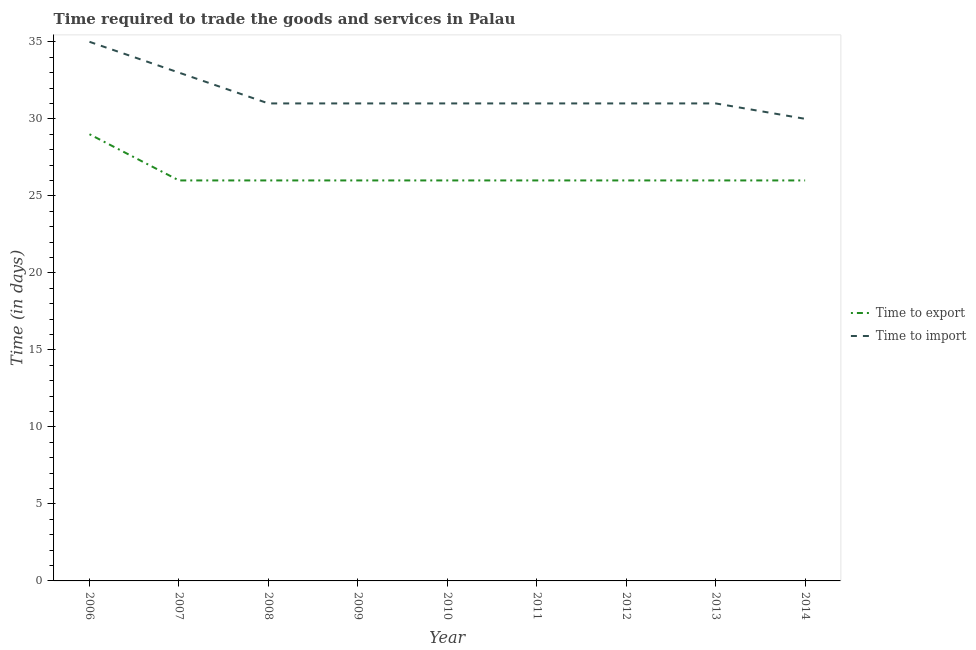How many different coloured lines are there?
Keep it short and to the point. 2. Is the number of lines equal to the number of legend labels?
Offer a very short reply. Yes. What is the time to import in 2014?
Offer a very short reply. 30. Across all years, what is the maximum time to import?
Your answer should be compact. 35. Across all years, what is the minimum time to export?
Provide a short and direct response. 26. In which year was the time to import minimum?
Keep it short and to the point. 2014. What is the total time to export in the graph?
Your answer should be compact. 237. What is the difference between the time to import in 2008 and that in 2009?
Your answer should be very brief. 0. What is the difference between the time to import in 2006 and the time to export in 2008?
Provide a short and direct response. 9. What is the average time to export per year?
Provide a succinct answer. 26.33. In the year 2010, what is the difference between the time to import and time to export?
Ensure brevity in your answer.  5. In how many years, is the time to import greater than 2 days?
Your answer should be very brief. 9. What is the ratio of the time to import in 2007 to that in 2010?
Offer a very short reply. 1.06. Is the time to export in 2006 less than that in 2008?
Your answer should be compact. No. Is the difference between the time to export in 2007 and 2011 greater than the difference between the time to import in 2007 and 2011?
Your answer should be very brief. No. What is the difference between the highest and the lowest time to import?
Your response must be concise. 5. Is the sum of the time to import in 2008 and 2012 greater than the maximum time to export across all years?
Make the answer very short. Yes. Does the time to export monotonically increase over the years?
Your answer should be compact. No. Is the time to import strictly greater than the time to export over the years?
Ensure brevity in your answer.  Yes. Is the time to import strictly less than the time to export over the years?
Your answer should be very brief. No. How many lines are there?
Your answer should be very brief. 2. Does the graph contain any zero values?
Provide a short and direct response. No. Does the graph contain grids?
Provide a short and direct response. No. How many legend labels are there?
Provide a succinct answer. 2. How are the legend labels stacked?
Provide a succinct answer. Vertical. What is the title of the graph?
Offer a terse response. Time required to trade the goods and services in Palau. Does "Commercial bank branches" appear as one of the legend labels in the graph?
Keep it short and to the point. No. What is the label or title of the X-axis?
Offer a very short reply. Year. What is the label or title of the Y-axis?
Your answer should be compact. Time (in days). What is the Time (in days) of Time to export in 2006?
Your answer should be very brief. 29. What is the Time (in days) in Time to import in 2006?
Offer a terse response. 35. What is the Time (in days) in Time to export in 2007?
Provide a succinct answer. 26. What is the Time (in days) of Time to import in 2008?
Your answer should be compact. 31. What is the Time (in days) in Time to export in 2009?
Ensure brevity in your answer.  26. What is the Time (in days) of Time to export in 2011?
Provide a short and direct response. 26. What is the Time (in days) of Time to import in 2011?
Your answer should be compact. 31. What is the Time (in days) in Time to import in 2013?
Give a very brief answer. 31. What is the Time (in days) in Time to import in 2014?
Make the answer very short. 30. Across all years, what is the maximum Time (in days) of Time to import?
Ensure brevity in your answer.  35. Across all years, what is the minimum Time (in days) in Time to import?
Provide a succinct answer. 30. What is the total Time (in days) in Time to export in the graph?
Your answer should be very brief. 237. What is the total Time (in days) of Time to import in the graph?
Offer a very short reply. 284. What is the difference between the Time (in days) of Time to export in 2006 and that in 2007?
Give a very brief answer. 3. What is the difference between the Time (in days) of Time to import in 2006 and that in 2007?
Your answer should be very brief. 2. What is the difference between the Time (in days) of Time to export in 2006 and that in 2008?
Keep it short and to the point. 3. What is the difference between the Time (in days) of Time to export in 2006 and that in 2009?
Offer a terse response. 3. What is the difference between the Time (in days) of Time to import in 2006 and that in 2009?
Your answer should be compact. 4. What is the difference between the Time (in days) in Time to export in 2006 and that in 2010?
Offer a terse response. 3. What is the difference between the Time (in days) in Time to export in 2006 and that in 2011?
Offer a terse response. 3. What is the difference between the Time (in days) in Time to import in 2006 and that in 2013?
Ensure brevity in your answer.  4. What is the difference between the Time (in days) of Time to export in 2007 and that in 2008?
Keep it short and to the point. 0. What is the difference between the Time (in days) in Time to import in 2007 and that in 2008?
Provide a short and direct response. 2. What is the difference between the Time (in days) of Time to import in 2007 and that in 2009?
Your answer should be compact. 2. What is the difference between the Time (in days) of Time to export in 2007 and that in 2010?
Offer a very short reply. 0. What is the difference between the Time (in days) in Time to export in 2007 and that in 2011?
Your answer should be compact. 0. What is the difference between the Time (in days) of Time to export in 2007 and that in 2013?
Offer a very short reply. 0. What is the difference between the Time (in days) of Time to export in 2007 and that in 2014?
Ensure brevity in your answer.  0. What is the difference between the Time (in days) of Time to export in 2008 and that in 2009?
Offer a terse response. 0. What is the difference between the Time (in days) in Time to import in 2008 and that in 2009?
Make the answer very short. 0. What is the difference between the Time (in days) of Time to import in 2008 and that in 2010?
Your response must be concise. 0. What is the difference between the Time (in days) in Time to export in 2008 and that in 2011?
Keep it short and to the point. 0. What is the difference between the Time (in days) in Time to export in 2008 and that in 2012?
Make the answer very short. 0. What is the difference between the Time (in days) in Time to export in 2008 and that in 2013?
Your answer should be compact. 0. What is the difference between the Time (in days) of Time to export in 2008 and that in 2014?
Offer a terse response. 0. What is the difference between the Time (in days) in Time to import in 2008 and that in 2014?
Your answer should be compact. 1. What is the difference between the Time (in days) of Time to export in 2009 and that in 2010?
Provide a short and direct response. 0. What is the difference between the Time (in days) in Time to import in 2009 and that in 2011?
Ensure brevity in your answer.  0. What is the difference between the Time (in days) in Time to export in 2009 and that in 2012?
Give a very brief answer. 0. What is the difference between the Time (in days) in Time to export in 2009 and that in 2013?
Your answer should be compact. 0. What is the difference between the Time (in days) in Time to import in 2009 and that in 2013?
Your response must be concise. 0. What is the difference between the Time (in days) in Time to export in 2009 and that in 2014?
Provide a succinct answer. 0. What is the difference between the Time (in days) in Time to export in 2010 and that in 2011?
Ensure brevity in your answer.  0. What is the difference between the Time (in days) of Time to import in 2010 and that in 2011?
Offer a terse response. 0. What is the difference between the Time (in days) in Time to export in 2010 and that in 2013?
Ensure brevity in your answer.  0. What is the difference between the Time (in days) in Time to import in 2010 and that in 2013?
Your answer should be compact. 0. What is the difference between the Time (in days) of Time to export in 2010 and that in 2014?
Offer a terse response. 0. What is the difference between the Time (in days) of Time to import in 2010 and that in 2014?
Your response must be concise. 1. What is the difference between the Time (in days) of Time to export in 2011 and that in 2012?
Your answer should be very brief. 0. What is the difference between the Time (in days) in Time to import in 2011 and that in 2012?
Keep it short and to the point. 0. What is the difference between the Time (in days) in Time to export in 2011 and that in 2013?
Provide a short and direct response. 0. What is the difference between the Time (in days) of Time to export in 2011 and that in 2014?
Ensure brevity in your answer.  0. What is the difference between the Time (in days) in Time to export in 2012 and that in 2013?
Provide a succinct answer. 0. What is the difference between the Time (in days) of Time to export in 2012 and that in 2014?
Keep it short and to the point. 0. What is the difference between the Time (in days) in Time to import in 2013 and that in 2014?
Provide a short and direct response. 1. What is the difference between the Time (in days) of Time to export in 2006 and the Time (in days) of Time to import in 2007?
Keep it short and to the point. -4. What is the difference between the Time (in days) in Time to export in 2006 and the Time (in days) in Time to import in 2008?
Offer a very short reply. -2. What is the difference between the Time (in days) in Time to export in 2006 and the Time (in days) in Time to import in 2009?
Make the answer very short. -2. What is the difference between the Time (in days) of Time to export in 2006 and the Time (in days) of Time to import in 2010?
Offer a very short reply. -2. What is the difference between the Time (in days) in Time to export in 2006 and the Time (in days) in Time to import in 2011?
Your response must be concise. -2. What is the difference between the Time (in days) of Time to export in 2006 and the Time (in days) of Time to import in 2013?
Ensure brevity in your answer.  -2. What is the difference between the Time (in days) in Time to export in 2007 and the Time (in days) in Time to import in 2010?
Provide a short and direct response. -5. What is the difference between the Time (in days) in Time to export in 2008 and the Time (in days) in Time to import in 2010?
Make the answer very short. -5. What is the difference between the Time (in days) in Time to export in 2008 and the Time (in days) in Time to import in 2011?
Keep it short and to the point. -5. What is the difference between the Time (in days) of Time to export in 2008 and the Time (in days) of Time to import in 2012?
Provide a succinct answer. -5. What is the difference between the Time (in days) of Time to export in 2009 and the Time (in days) of Time to import in 2011?
Give a very brief answer. -5. What is the difference between the Time (in days) in Time to export in 2009 and the Time (in days) in Time to import in 2012?
Ensure brevity in your answer.  -5. What is the difference between the Time (in days) of Time to export in 2009 and the Time (in days) of Time to import in 2014?
Keep it short and to the point. -4. What is the difference between the Time (in days) of Time to export in 2010 and the Time (in days) of Time to import in 2013?
Make the answer very short. -5. What is the difference between the Time (in days) of Time to export in 2010 and the Time (in days) of Time to import in 2014?
Offer a very short reply. -4. What is the difference between the Time (in days) in Time to export in 2011 and the Time (in days) in Time to import in 2013?
Make the answer very short. -5. What is the difference between the Time (in days) of Time to export in 2011 and the Time (in days) of Time to import in 2014?
Your response must be concise. -4. What is the difference between the Time (in days) in Time to export in 2012 and the Time (in days) in Time to import in 2014?
Give a very brief answer. -4. What is the difference between the Time (in days) of Time to export in 2013 and the Time (in days) of Time to import in 2014?
Make the answer very short. -4. What is the average Time (in days) in Time to export per year?
Give a very brief answer. 26.33. What is the average Time (in days) of Time to import per year?
Provide a succinct answer. 31.56. In the year 2007, what is the difference between the Time (in days) in Time to export and Time (in days) in Time to import?
Offer a very short reply. -7. In the year 2008, what is the difference between the Time (in days) in Time to export and Time (in days) in Time to import?
Provide a short and direct response. -5. In the year 2010, what is the difference between the Time (in days) in Time to export and Time (in days) in Time to import?
Give a very brief answer. -5. In the year 2011, what is the difference between the Time (in days) of Time to export and Time (in days) of Time to import?
Give a very brief answer. -5. In the year 2013, what is the difference between the Time (in days) of Time to export and Time (in days) of Time to import?
Offer a very short reply. -5. What is the ratio of the Time (in days) in Time to export in 2006 to that in 2007?
Ensure brevity in your answer.  1.12. What is the ratio of the Time (in days) of Time to import in 2006 to that in 2007?
Ensure brevity in your answer.  1.06. What is the ratio of the Time (in days) of Time to export in 2006 to that in 2008?
Offer a terse response. 1.12. What is the ratio of the Time (in days) of Time to import in 2006 to that in 2008?
Keep it short and to the point. 1.13. What is the ratio of the Time (in days) in Time to export in 2006 to that in 2009?
Offer a terse response. 1.12. What is the ratio of the Time (in days) in Time to import in 2006 to that in 2009?
Offer a terse response. 1.13. What is the ratio of the Time (in days) of Time to export in 2006 to that in 2010?
Make the answer very short. 1.12. What is the ratio of the Time (in days) in Time to import in 2006 to that in 2010?
Keep it short and to the point. 1.13. What is the ratio of the Time (in days) in Time to export in 2006 to that in 2011?
Give a very brief answer. 1.12. What is the ratio of the Time (in days) of Time to import in 2006 to that in 2011?
Provide a short and direct response. 1.13. What is the ratio of the Time (in days) of Time to export in 2006 to that in 2012?
Ensure brevity in your answer.  1.12. What is the ratio of the Time (in days) in Time to import in 2006 to that in 2012?
Your response must be concise. 1.13. What is the ratio of the Time (in days) of Time to export in 2006 to that in 2013?
Give a very brief answer. 1.12. What is the ratio of the Time (in days) of Time to import in 2006 to that in 2013?
Offer a terse response. 1.13. What is the ratio of the Time (in days) in Time to export in 2006 to that in 2014?
Your answer should be very brief. 1.12. What is the ratio of the Time (in days) of Time to import in 2006 to that in 2014?
Your response must be concise. 1.17. What is the ratio of the Time (in days) in Time to export in 2007 to that in 2008?
Offer a very short reply. 1. What is the ratio of the Time (in days) in Time to import in 2007 to that in 2008?
Your answer should be compact. 1.06. What is the ratio of the Time (in days) of Time to export in 2007 to that in 2009?
Your answer should be compact. 1. What is the ratio of the Time (in days) of Time to import in 2007 to that in 2009?
Provide a succinct answer. 1.06. What is the ratio of the Time (in days) in Time to export in 2007 to that in 2010?
Your answer should be compact. 1. What is the ratio of the Time (in days) in Time to import in 2007 to that in 2010?
Your answer should be compact. 1.06. What is the ratio of the Time (in days) of Time to import in 2007 to that in 2011?
Your response must be concise. 1.06. What is the ratio of the Time (in days) of Time to export in 2007 to that in 2012?
Provide a succinct answer. 1. What is the ratio of the Time (in days) in Time to import in 2007 to that in 2012?
Offer a very short reply. 1.06. What is the ratio of the Time (in days) in Time to import in 2007 to that in 2013?
Give a very brief answer. 1.06. What is the ratio of the Time (in days) in Time to export in 2008 to that in 2009?
Your answer should be compact. 1. What is the ratio of the Time (in days) of Time to import in 2008 to that in 2013?
Keep it short and to the point. 1. What is the ratio of the Time (in days) in Time to export in 2008 to that in 2014?
Provide a succinct answer. 1. What is the ratio of the Time (in days) in Time to import in 2008 to that in 2014?
Provide a succinct answer. 1.03. What is the ratio of the Time (in days) of Time to export in 2009 to that in 2010?
Your answer should be compact. 1. What is the ratio of the Time (in days) of Time to export in 2009 to that in 2011?
Your response must be concise. 1. What is the ratio of the Time (in days) of Time to export in 2009 to that in 2012?
Your response must be concise. 1. What is the ratio of the Time (in days) in Time to import in 2009 to that in 2013?
Offer a terse response. 1. What is the ratio of the Time (in days) in Time to export in 2010 to that in 2011?
Your answer should be compact. 1. What is the ratio of the Time (in days) in Time to import in 2010 to that in 2011?
Ensure brevity in your answer.  1. What is the ratio of the Time (in days) of Time to export in 2010 to that in 2013?
Offer a very short reply. 1. What is the ratio of the Time (in days) in Time to import in 2010 to that in 2013?
Ensure brevity in your answer.  1. What is the ratio of the Time (in days) of Time to import in 2010 to that in 2014?
Make the answer very short. 1.03. What is the ratio of the Time (in days) of Time to export in 2011 to that in 2012?
Provide a short and direct response. 1. What is the ratio of the Time (in days) in Time to import in 2011 to that in 2012?
Make the answer very short. 1. What is the ratio of the Time (in days) in Time to export in 2011 to that in 2013?
Keep it short and to the point. 1. What is the ratio of the Time (in days) of Time to import in 2011 to that in 2014?
Your answer should be very brief. 1.03. What is the ratio of the Time (in days) of Time to import in 2012 to that in 2013?
Ensure brevity in your answer.  1. What is the ratio of the Time (in days) in Time to export in 2012 to that in 2014?
Ensure brevity in your answer.  1. What is the ratio of the Time (in days) of Time to export in 2013 to that in 2014?
Offer a terse response. 1. What is the ratio of the Time (in days) in Time to import in 2013 to that in 2014?
Make the answer very short. 1.03. What is the difference between the highest and the lowest Time (in days) in Time to export?
Offer a very short reply. 3. 